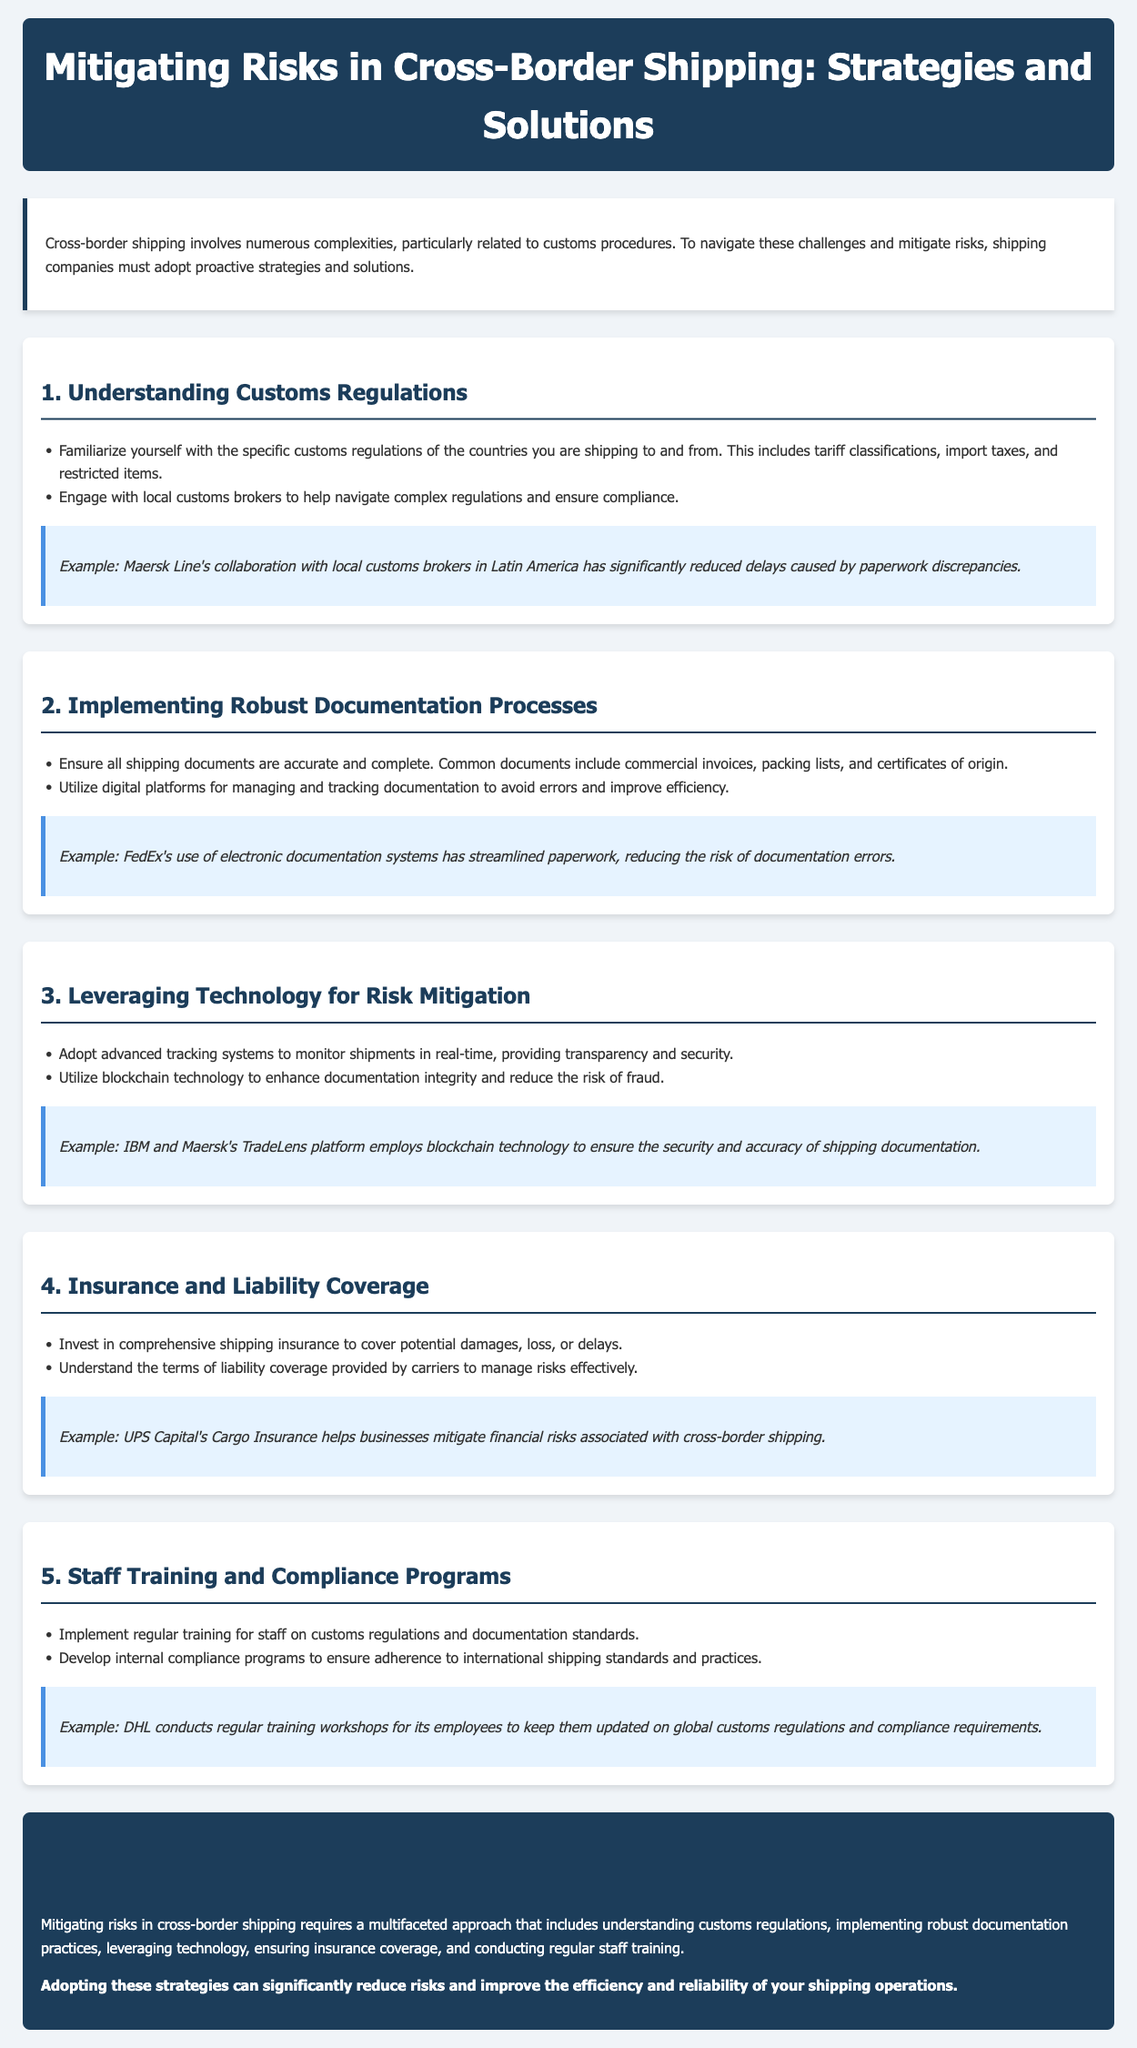What is the title of the lesson plan? The title of the lesson plan is the main heading of the document.
Answer: Mitigating Risks in Cross-Border Shipping: Strategies and Solutions What is the first strategy mentioned for mitigating risks? The first strategy is listed in the structured format of the document as a section title.
Answer: Understanding Customs Regulations Which shipping company collaborated with local customs brokers in Latin America? This shipping company's practical example is provided in the case study to illustrate the strategy.
Answer: Maersk Line What technology is used to enhance documentation integrity? The lesson plan discusses multiple technologies, highlighting this specific one used for improvement.
Answer: Blockchain technology What type of insurance is advised for shipping businesses? This is mentioned as a recommendation for mitigating financial risks associated with shipping.
Answer: Comprehensive shipping insurance How often should staff training be conducted? The lesson plan implies the schedule for training but does not specify a frequency.
Answer: Regularly What is the last section of the document titled? The final section of the document wraps up the discussion and is formatted as a section title.
Answer: Conclusion What is a key component of the comprehensive shipping insurance mentioned? This aspect focuses on potential shipping issues that the insurance should cover.
Answer: Damage, loss, or delays Which company uses electronic documentation systems to reduce errors? This company is used as an example in the lesson plan to show the effectiveness of the strategy.
Answer: FedEx 